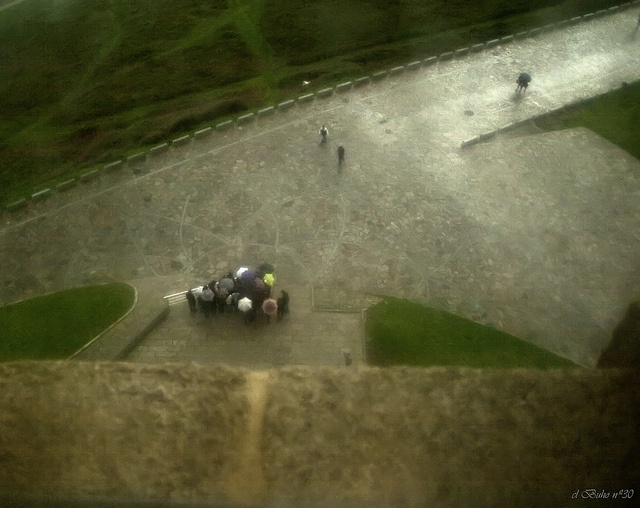Describe the objects in this image and their specific colors. I can see umbrella in darkgreen, black, and gray tones, bench in darkgreen, olive, tan, and beige tones, umbrella in darkgreen, gray, black, and tan tones, people in darkgreen, black, and gray tones, and umbrella in darkgreen, gray, and black tones in this image. 